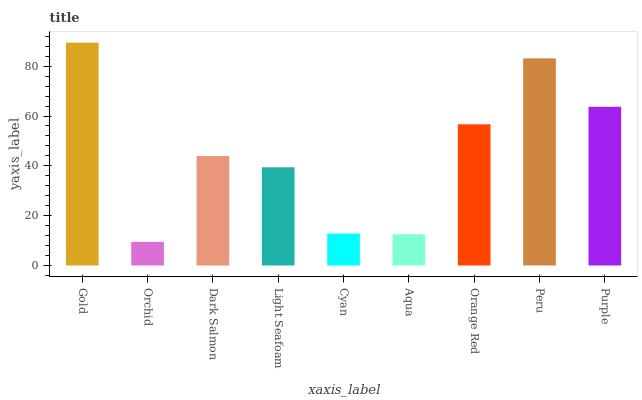Is Orchid the minimum?
Answer yes or no. Yes. Is Gold the maximum?
Answer yes or no. Yes. Is Dark Salmon the minimum?
Answer yes or no. No. Is Dark Salmon the maximum?
Answer yes or no. No. Is Dark Salmon greater than Orchid?
Answer yes or no. Yes. Is Orchid less than Dark Salmon?
Answer yes or no. Yes. Is Orchid greater than Dark Salmon?
Answer yes or no. No. Is Dark Salmon less than Orchid?
Answer yes or no. No. Is Dark Salmon the high median?
Answer yes or no. Yes. Is Dark Salmon the low median?
Answer yes or no. Yes. Is Purple the high median?
Answer yes or no. No. Is Cyan the low median?
Answer yes or no. No. 